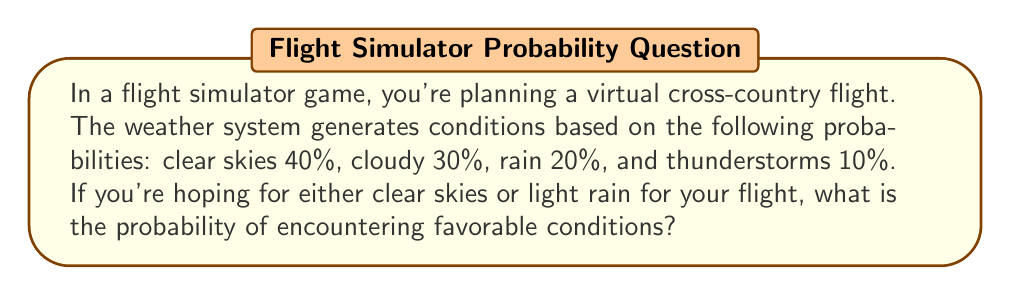Give your solution to this math problem. Let's approach this step-by-step:

1) First, we need to identify the favorable conditions:
   - Clear skies: 40% or 0.40
   - Light rain: 20% or 0.20

2) To find the probability of encountering either of these conditions, we add their individual probabilities:

   $$P(\text{favorable conditions}) = P(\text{clear skies}) + P(\text{light rain})$$

3) Substituting the values:

   $$P(\text{favorable conditions}) = 0.40 + 0.20$$

4) Performing the addition:

   $$P(\text{favorable conditions}) = 0.60$$

5) Convert to percentage:

   $$P(\text{favorable conditions}) = 60\%$$

Therefore, the probability of encountering favorable conditions (either clear skies or light rain) for your virtual flight is 60% or 0.60.
Answer: 0.60 or 60% 